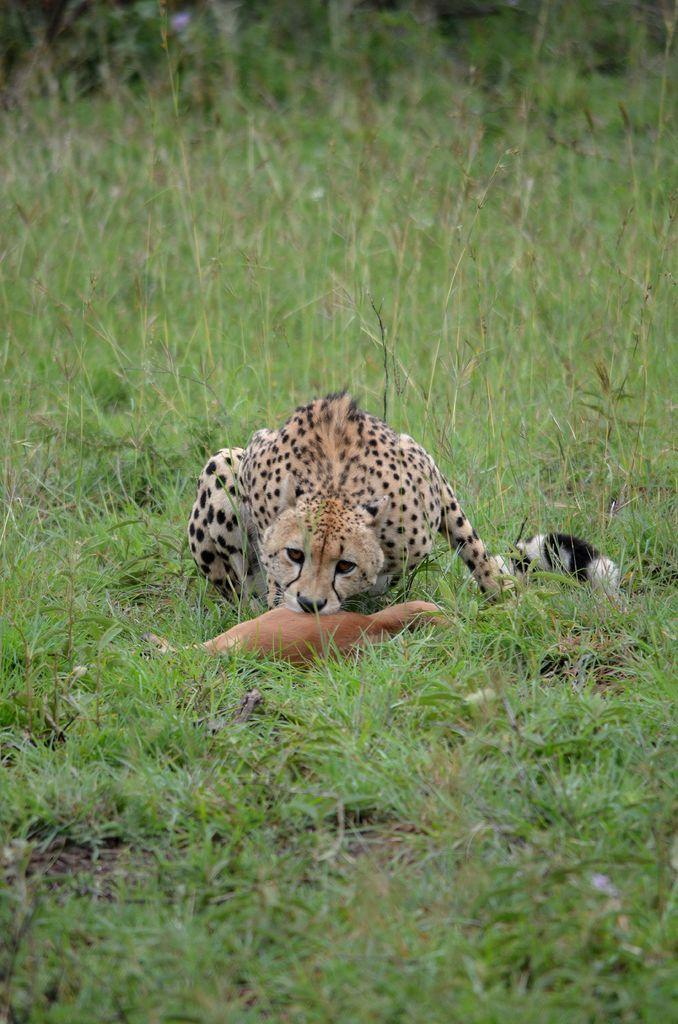What type of animal is the main subject in the image? There is a cheetah in the image. What is the cheetah doing in the image? The cheetah is eating a deer in the image. Where is the scene taking place? The scene is taking place on the grassland. What word is being exchanged between the cheetah and the deer in the image? There is no word exchange between the cheetah and the deer in the image, as animals do not communicate through words. 